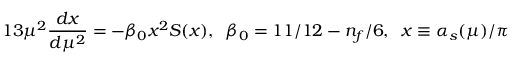<formula> <loc_0><loc_0><loc_500><loc_500>1 3 \mu ^ { 2 } \frac { d x } { d \mu ^ { 2 } } = - \beta _ { 0 } x ^ { 2 } S ( x ) , \, \beta _ { 0 } = 1 1 / 1 2 - n _ { f } / 6 , \, x \equiv \alpha _ { s } ( \mu ) / \pi</formula> 